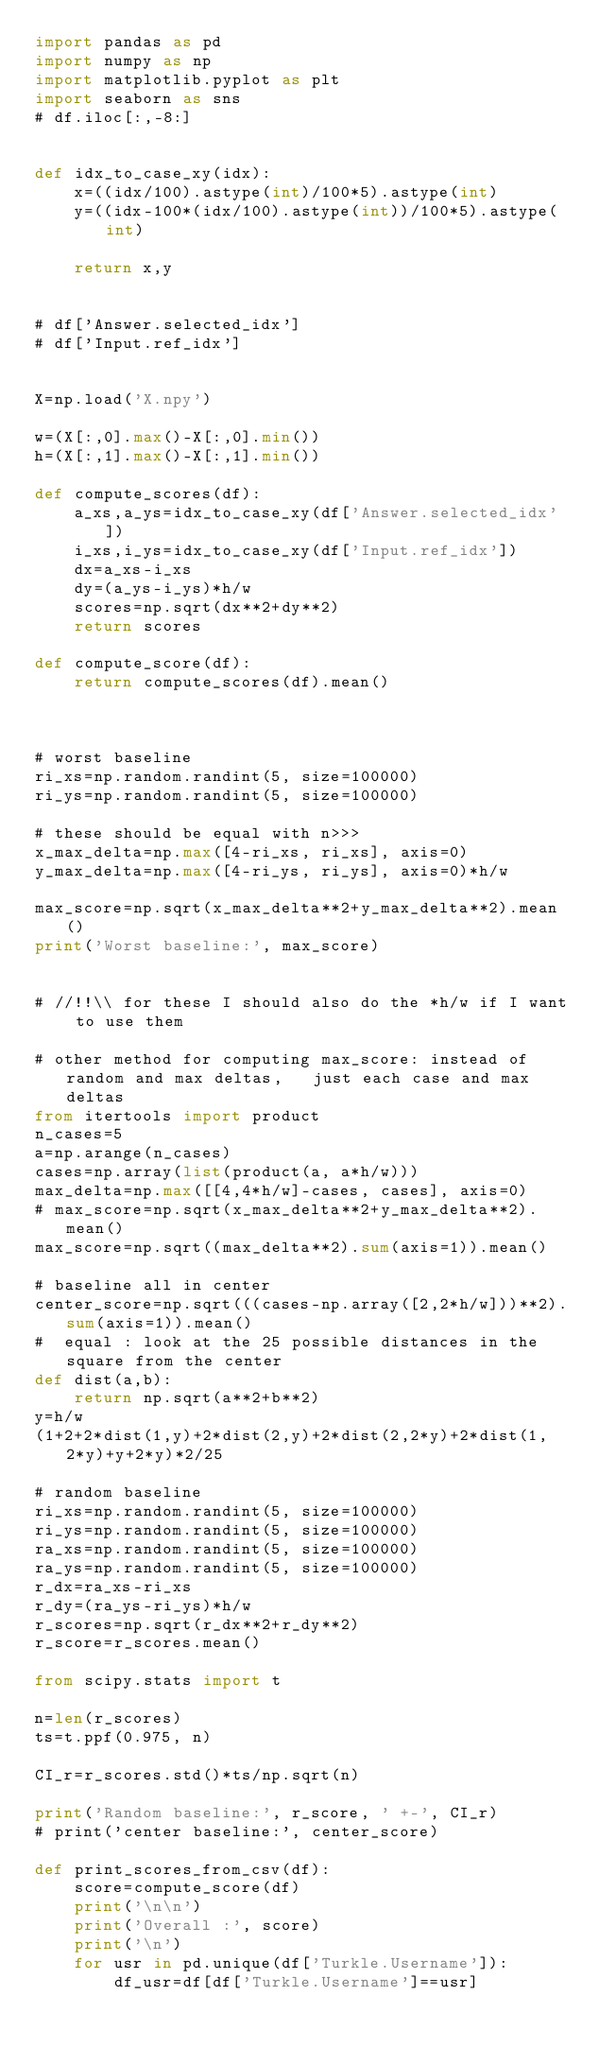<code> <loc_0><loc_0><loc_500><loc_500><_Python_>import pandas as pd
import numpy as np
import matplotlib.pyplot as plt
import seaborn as sns
# df.iloc[:,-8:]


def idx_to_case_xy(idx):
    x=((idx/100).astype(int)/100*5).astype(int)
    y=((idx-100*(idx/100).astype(int))/100*5).astype(int)

    return x,y


# df['Answer.selected_idx']
# df['Input.ref_idx']


X=np.load('X.npy')

w=(X[:,0].max()-X[:,0].min())
h=(X[:,1].max()-X[:,1].min())

def compute_scores(df):
    a_xs,a_ys=idx_to_case_xy(df['Answer.selected_idx'])
    i_xs,i_ys=idx_to_case_xy(df['Input.ref_idx'])
    dx=a_xs-i_xs
    dy=(a_ys-i_ys)*h/w
    scores=np.sqrt(dx**2+dy**2)
    return scores

def compute_score(df):
    return compute_scores(df).mean()



# worst baseline
ri_xs=np.random.randint(5, size=100000)
ri_ys=np.random.randint(5, size=100000)

# these should be equal with n>>>
x_max_delta=np.max([4-ri_xs, ri_xs], axis=0)
y_max_delta=np.max([4-ri_ys, ri_ys], axis=0)*h/w

max_score=np.sqrt(x_max_delta**2+y_max_delta**2).mean()
print('Worst baseline:', max_score)


# //!!\\ for these I should also do the *h/w if I want to use them

# other method for computing max_score: instead of random and max deltas,   just each case and max deltas
from itertools import product
n_cases=5
a=np.arange(n_cases)
cases=np.array(list(product(a, a*h/w)))
max_delta=np.max([[4,4*h/w]-cases, cases], axis=0)
# max_score=np.sqrt(x_max_delta**2+y_max_delta**2).mean()
max_score=np.sqrt((max_delta**2).sum(axis=1)).mean()

# baseline all in center
center_score=np.sqrt(((cases-np.array([2,2*h/w]))**2).sum(axis=1)).mean()
#  equal : look at the 25 possible distances in the square from the center
def dist(a,b):
    return np.sqrt(a**2+b**2)
y=h/w
(1+2+2*dist(1,y)+2*dist(2,y)+2*dist(2,2*y)+2*dist(1, 2*y)+y+2*y)*2/25

# random baseline
ri_xs=np.random.randint(5, size=100000)
ri_ys=np.random.randint(5, size=100000)
ra_xs=np.random.randint(5, size=100000)
ra_ys=np.random.randint(5, size=100000)
r_dx=ra_xs-ri_xs
r_dy=(ra_ys-ri_ys)*h/w
r_scores=np.sqrt(r_dx**2+r_dy**2)
r_score=r_scores.mean()

from scipy.stats import t

n=len(r_scores)
ts=t.ppf(0.975, n)

CI_r=r_scores.std()*ts/np.sqrt(n)

print('Random baseline:', r_score, ' +-', CI_r)
# print('center baseline:', center_score)

def print_scores_from_csv(df):
    score=compute_score(df)
    print('\n\n')
    print('Overall :', score)
    print('\n')
    for usr in pd.unique(df['Turkle.Username']):
        df_usr=df[df['Turkle.Username']==usr]</code> 